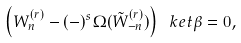Convert formula to latex. <formula><loc_0><loc_0><loc_500><loc_500>\left ( W ^ { ( r ) } _ { n } - ( - ) ^ { s } \Omega ( \tilde { W } ^ { ( r ) } _ { - n } ) \right ) \ k e t \beta = 0 ,</formula> 